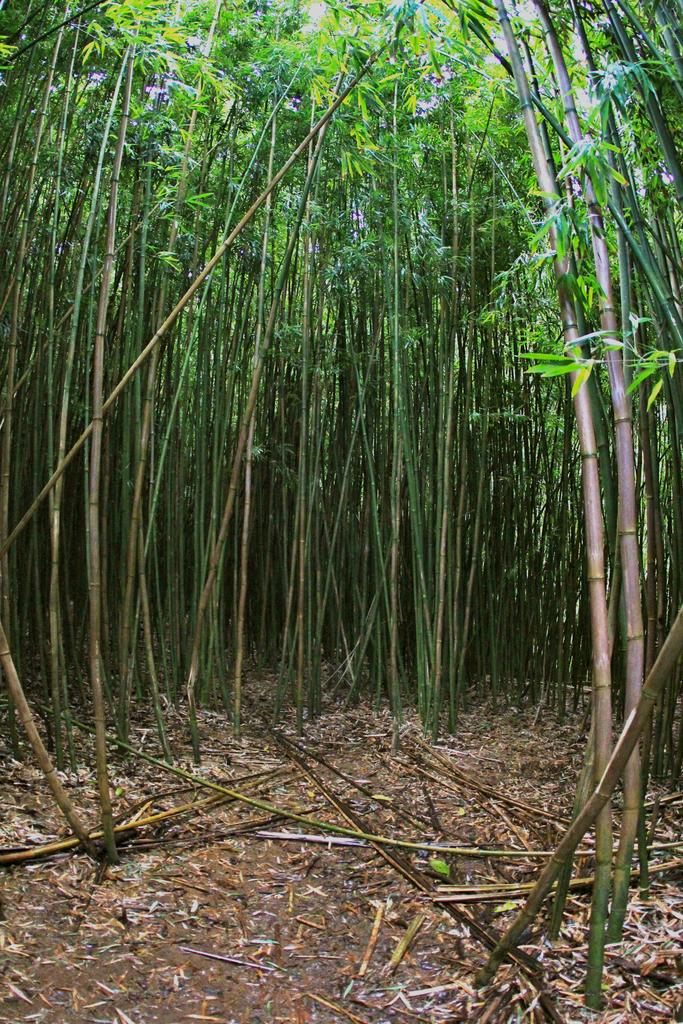What type of vegetation can be seen in the image? There are trees in the image. Can you describe the trees in the image? The provided facts do not include specific details about the trees, so we cannot describe them further. What might be the location of the image based on the presence of trees? The presence of trees suggests that the image might have been taken in a natural setting, such as a park or forest. What type of butter is being stored in the drawer near the seashore in the image? There is no butter or drawer present in the image, nor is there any reference to a seashore. 